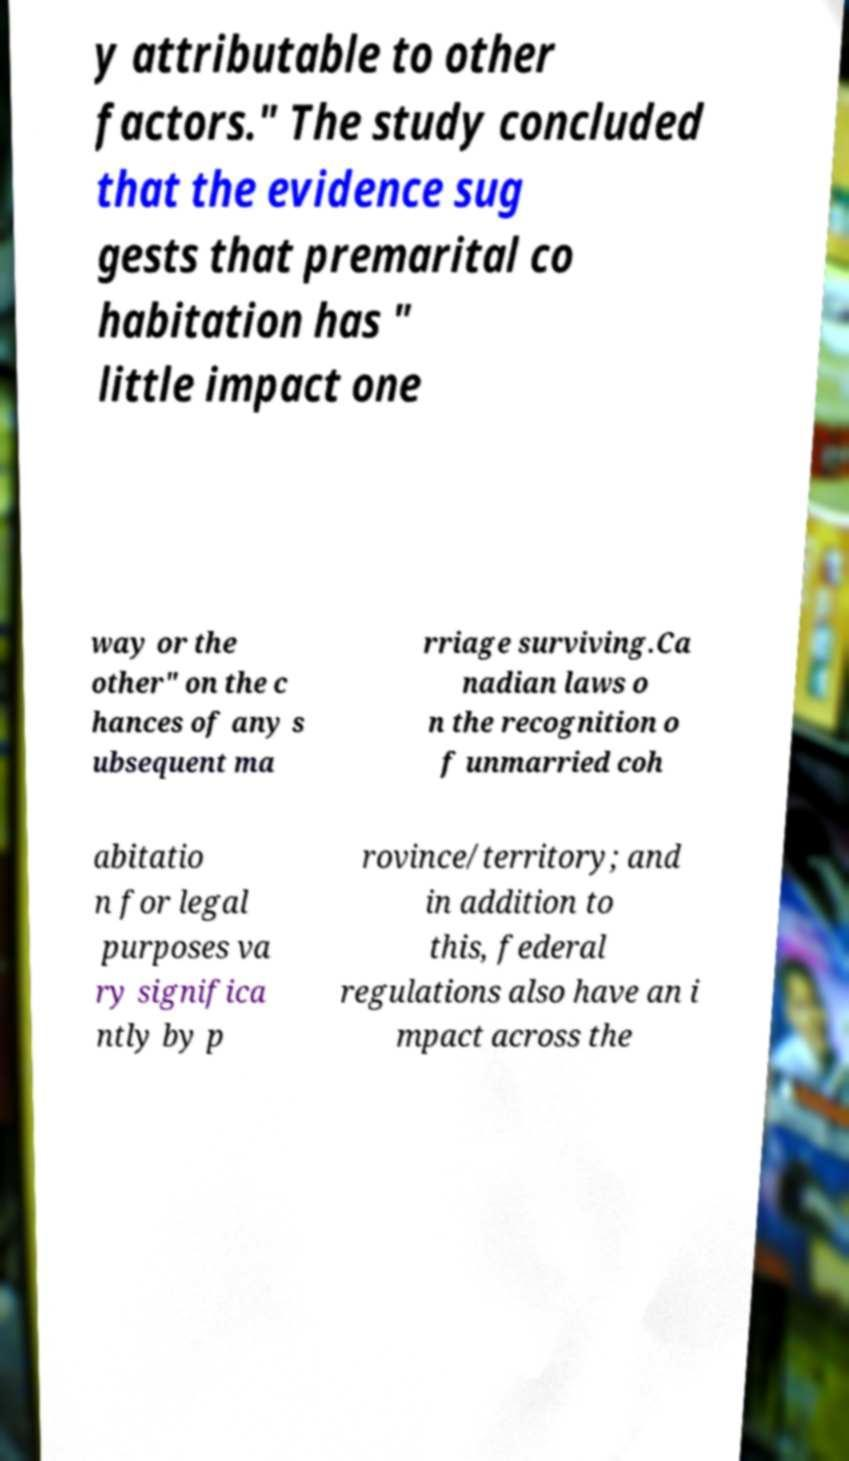There's text embedded in this image that I need extracted. Can you transcribe it verbatim? y attributable to other factors." The study concluded that the evidence sug gests that premarital co habitation has " little impact one way or the other" on the c hances of any s ubsequent ma rriage surviving.Ca nadian laws o n the recognition o f unmarried coh abitatio n for legal purposes va ry significa ntly by p rovince/territory; and in addition to this, federal regulations also have an i mpact across the 